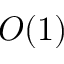<formula> <loc_0><loc_0><loc_500><loc_500>O ( 1 )</formula> 